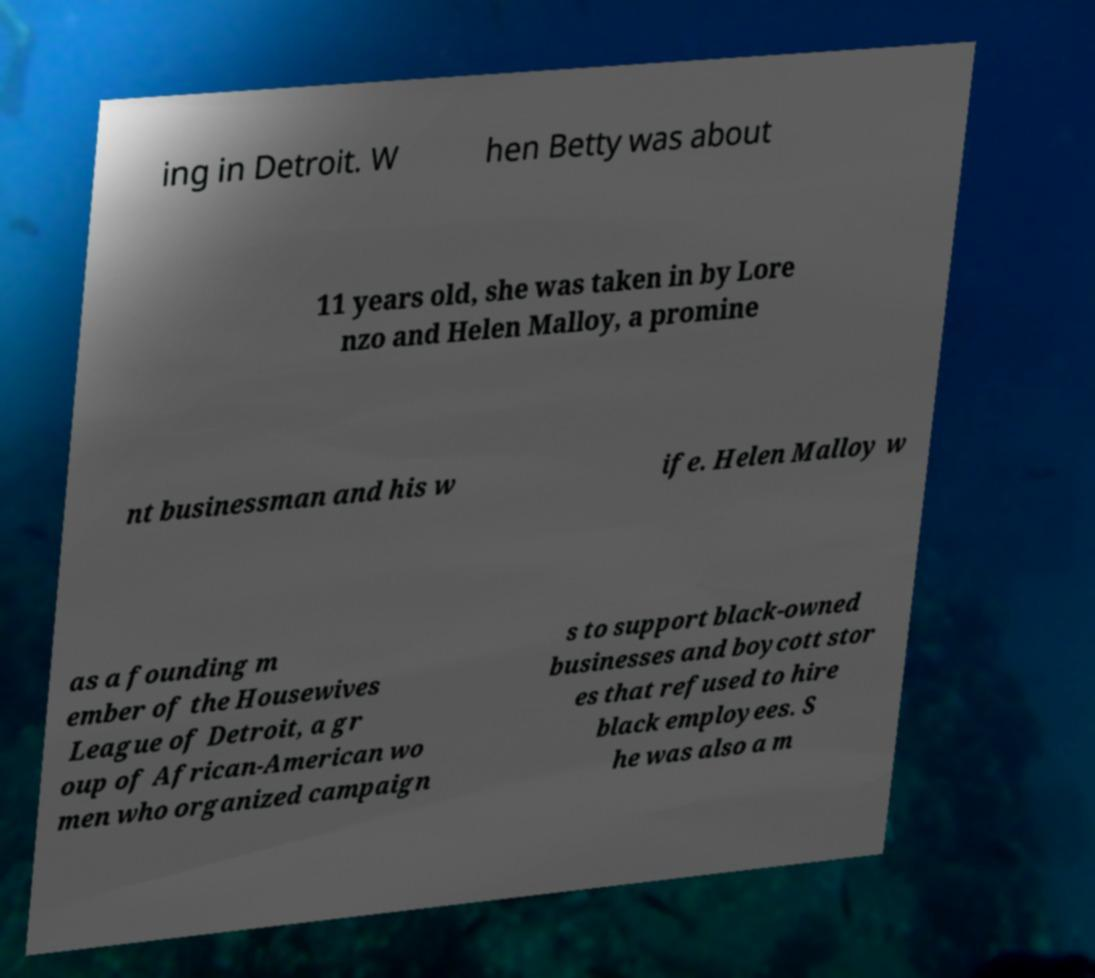I need the written content from this picture converted into text. Can you do that? ing in Detroit. W hen Betty was about 11 years old, she was taken in by Lore nzo and Helen Malloy, a promine nt businessman and his w ife. Helen Malloy w as a founding m ember of the Housewives League of Detroit, a gr oup of African-American wo men who organized campaign s to support black-owned businesses and boycott stor es that refused to hire black employees. S he was also a m 